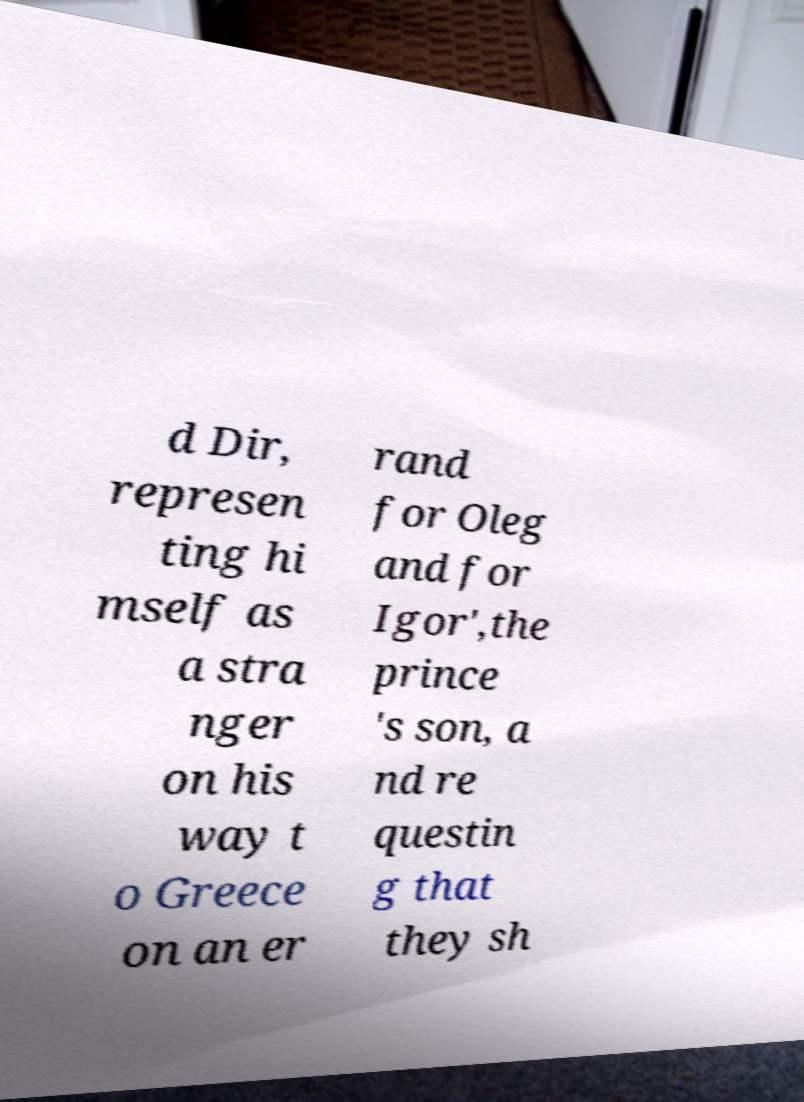Please read and relay the text visible in this image. What does it say? d Dir, represen ting hi mself as a stra nger on his way t o Greece on an er rand for Oleg and for Igor',the prince 's son, a nd re questin g that they sh 